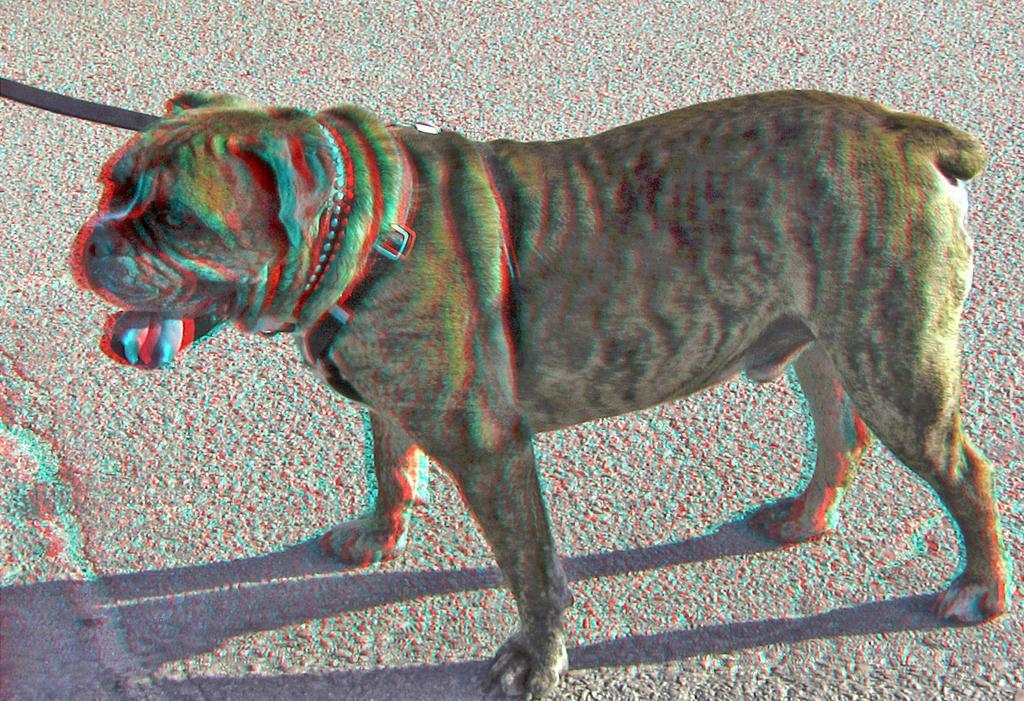Please provide a concise description of this image. Here in this picture we can see a Shar Pei present on the ground and we can see a belt around its neck present. 